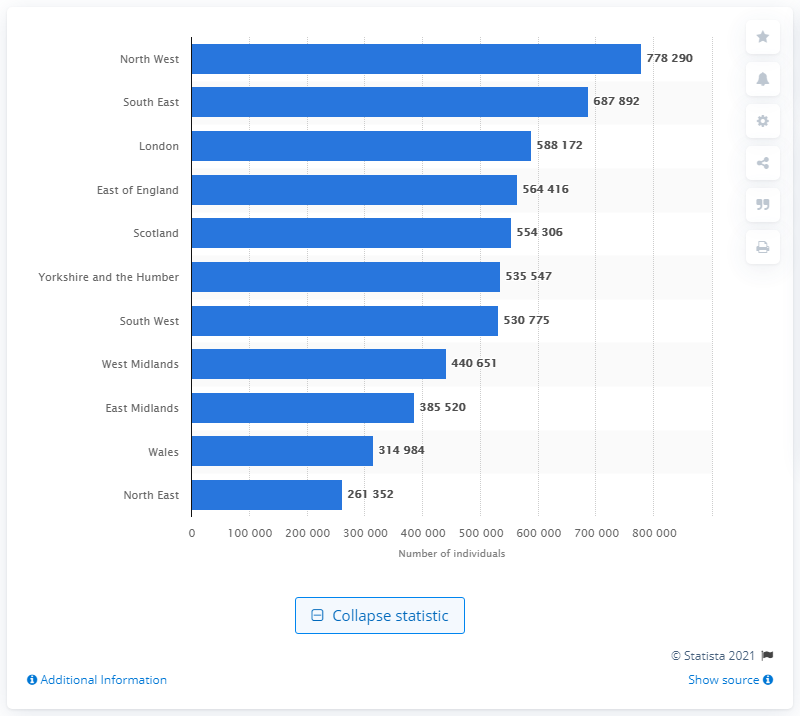How does the number of asthma cases in Wales compare with those in the North East? Wales has 314,984 individuals with asthma whereas the North East has 261,352. This means Wales has 53,632 more cases than the North East. 